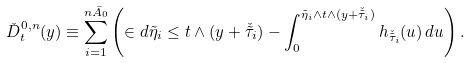Convert formula to latex. <formula><loc_0><loc_0><loc_500><loc_500>\check { D } _ { t } ^ { 0 , n } ( y ) \equiv \sum _ { i = 1 } ^ { n \bar { A } _ { 0 } } \left ( \in d { \tilde { \eta } _ { i } \leq t \wedge ( y + \check { \tilde { \tau } } _ { i } ) } - \int _ { 0 } ^ { \tilde { \eta } _ { i } \wedge t \wedge ( y + \check { \tilde { \tau } } _ { i } ) } h _ { \check { \tilde { \tau } } _ { i } } ( u ) \, d u \right ) .</formula> 